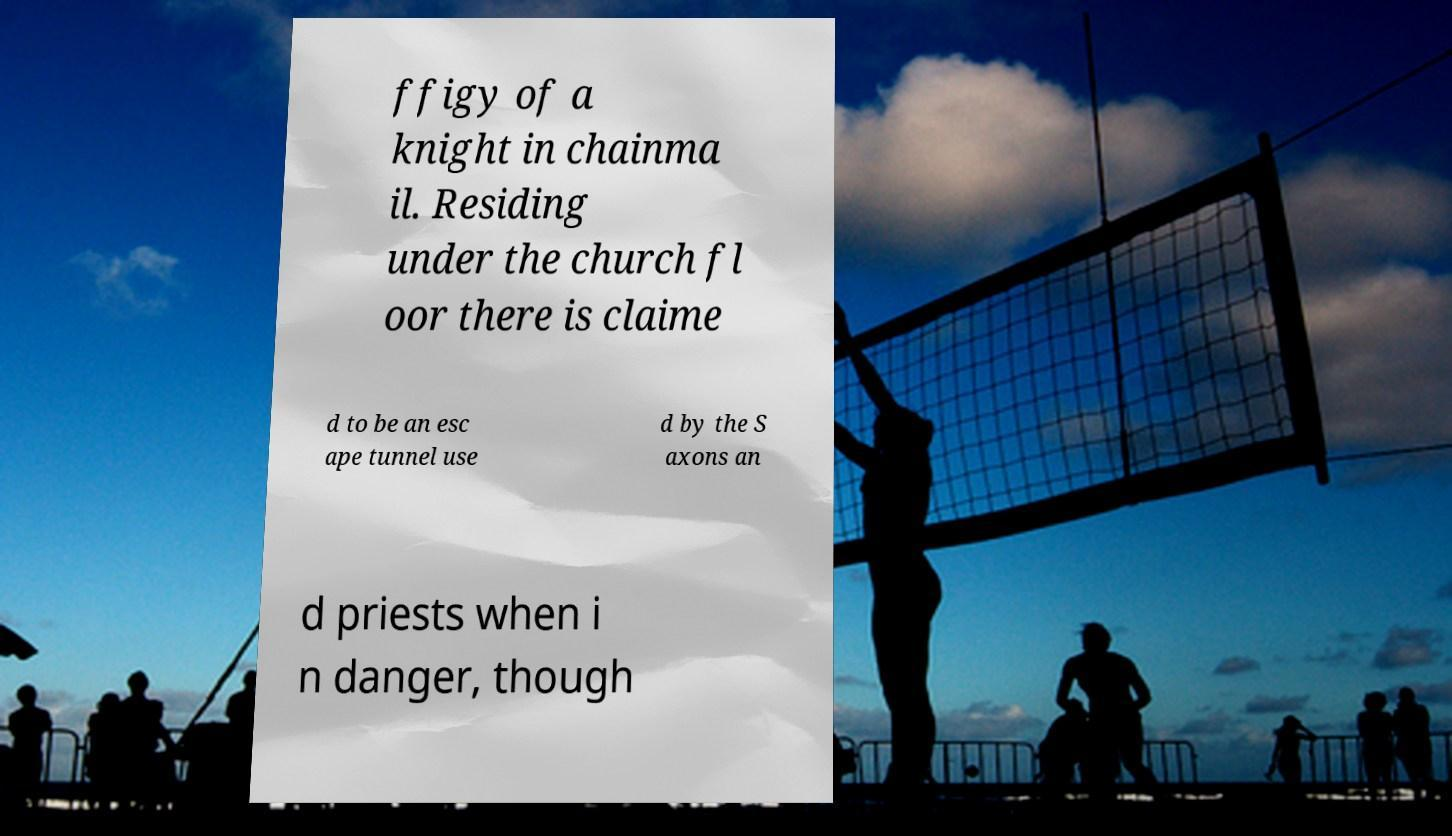I need the written content from this picture converted into text. Can you do that? ffigy of a knight in chainma il. Residing under the church fl oor there is claime d to be an esc ape tunnel use d by the S axons an d priests when i n danger, though 